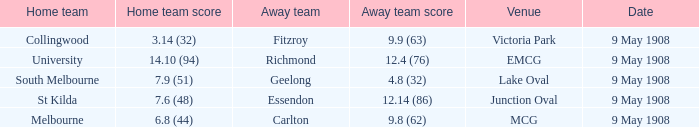Name the away team score for lake oval 4.8 (32). 